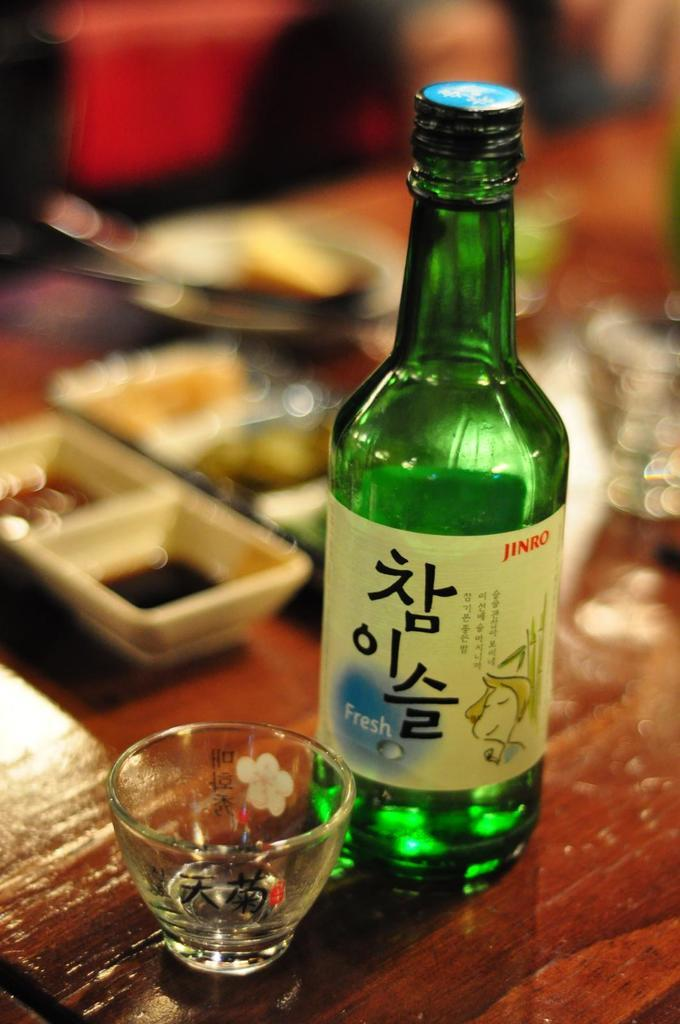<image>
Give a short and clear explanation of the subsequent image. A bottle of Fresh Jinro sits on a wooden table next to a small glass. 